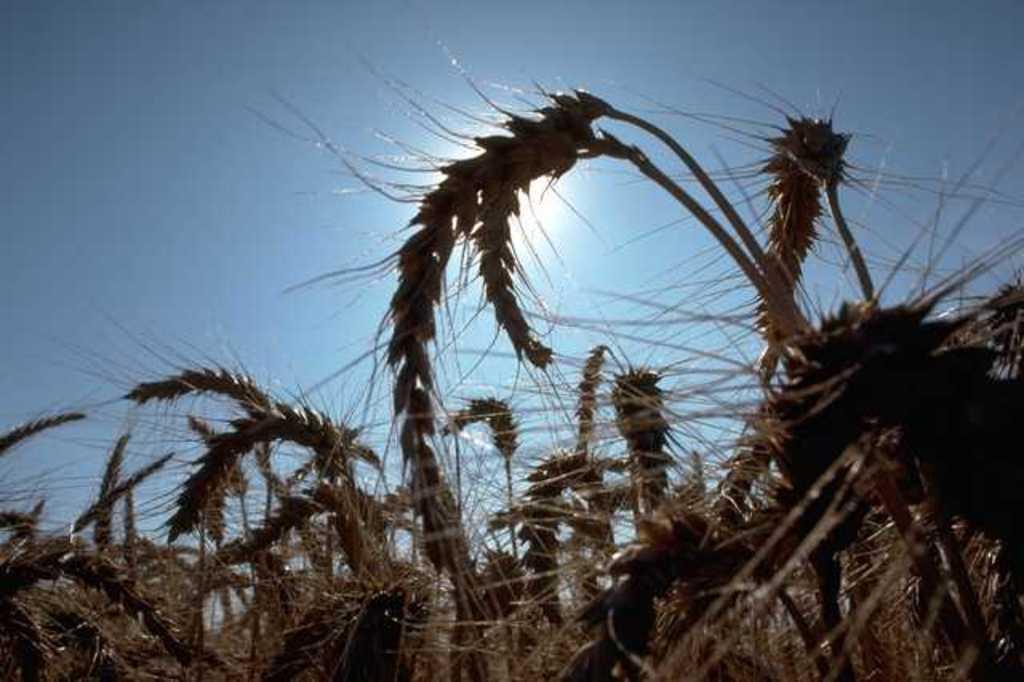Please provide a concise description of this image. In this picture we can see few plants and the sun. 